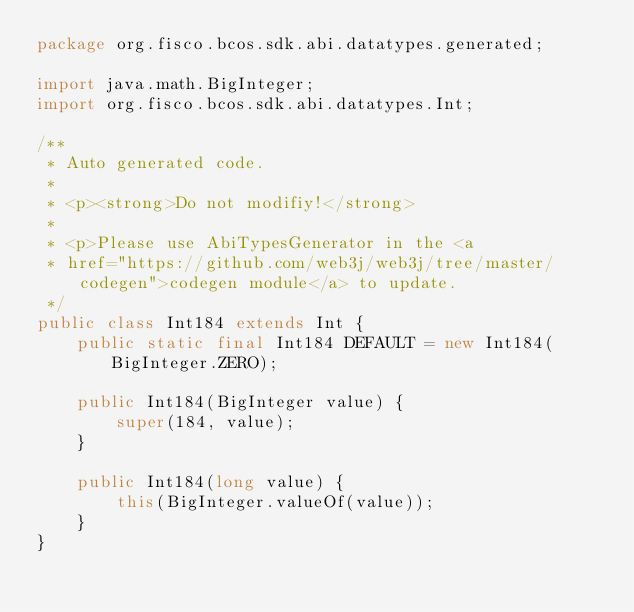<code> <loc_0><loc_0><loc_500><loc_500><_Java_>package org.fisco.bcos.sdk.abi.datatypes.generated;

import java.math.BigInteger;
import org.fisco.bcos.sdk.abi.datatypes.Int;

/**
 * Auto generated code.
 *
 * <p><strong>Do not modifiy!</strong>
 *
 * <p>Please use AbiTypesGenerator in the <a
 * href="https://github.com/web3j/web3j/tree/master/codegen">codegen module</a> to update.
 */
public class Int184 extends Int {
    public static final Int184 DEFAULT = new Int184(BigInteger.ZERO);

    public Int184(BigInteger value) {
        super(184, value);
    }

    public Int184(long value) {
        this(BigInteger.valueOf(value));
    }
}
</code> 